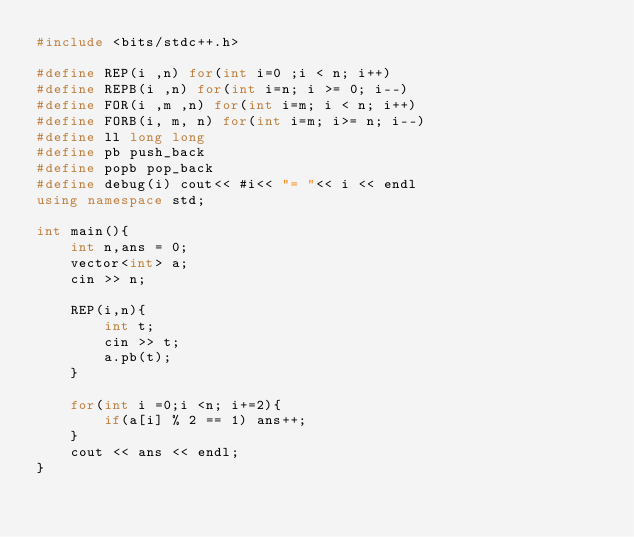<code> <loc_0><loc_0><loc_500><loc_500><_C++_>#include <bits/stdc++.h>

#define REP(i ,n) for(int i=0 ;i < n; i++)
#define REPB(i ,n) for(int i=n; i >= 0; i--)
#define FOR(i ,m ,n) for(int i=m; i < n; i++)
#define FORB(i, m, n) for(int i=m; i>= n; i--)
#define ll long long
#define pb push_back
#define popb pop_back
#define debug(i) cout<< #i<< "= "<< i << endl
using namespace std;

int main(){
    int n,ans = 0;
    vector<int> a;
    cin >> n;

    REP(i,n){
        int t;
        cin >> t;
        a.pb(t);
    }

    for(int i =0;i <n; i+=2){
        if(a[i] % 2 == 1) ans++;
    }
    cout << ans << endl;
}
</code> 